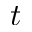Convert formula to latex. <formula><loc_0><loc_0><loc_500><loc_500>t</formula> 